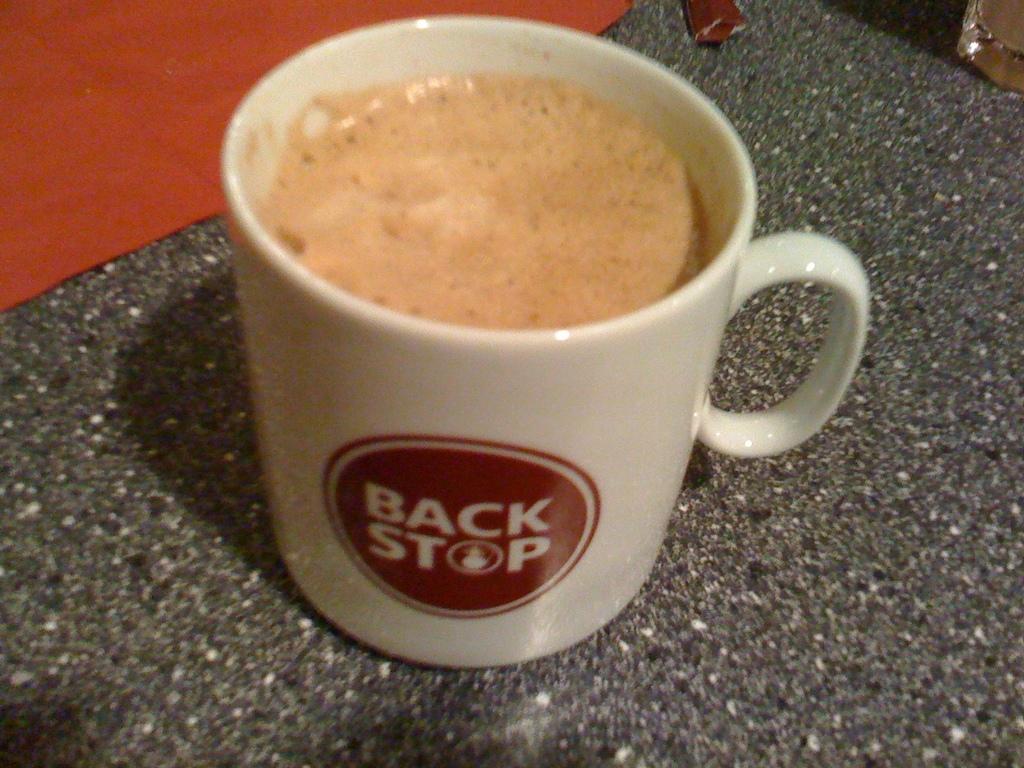Please provide a concise description of this image. In this image there is a coffee cup, on a stone surface, on the top left there is a cloth. 